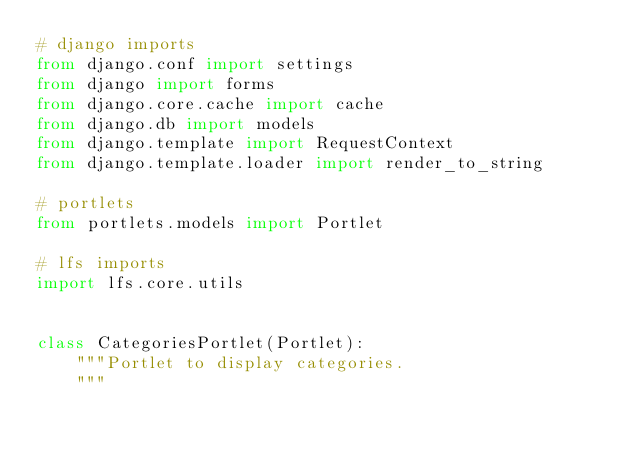<code> <loc_0><loc_0><loc_500><loc_500><_Python_># django imports
from django.conf import settings
from django import forms
from django.core.cache import cache
from django.db import models
from django.template import RequestContext
from django.template.loader import render_to_string

# portlets
from portlets.models import Portlet

# lfs imports
import lfs.core.utils


class CategoriesPortlet(Portlet):
    """Portlet to display categories.
    """</code> 